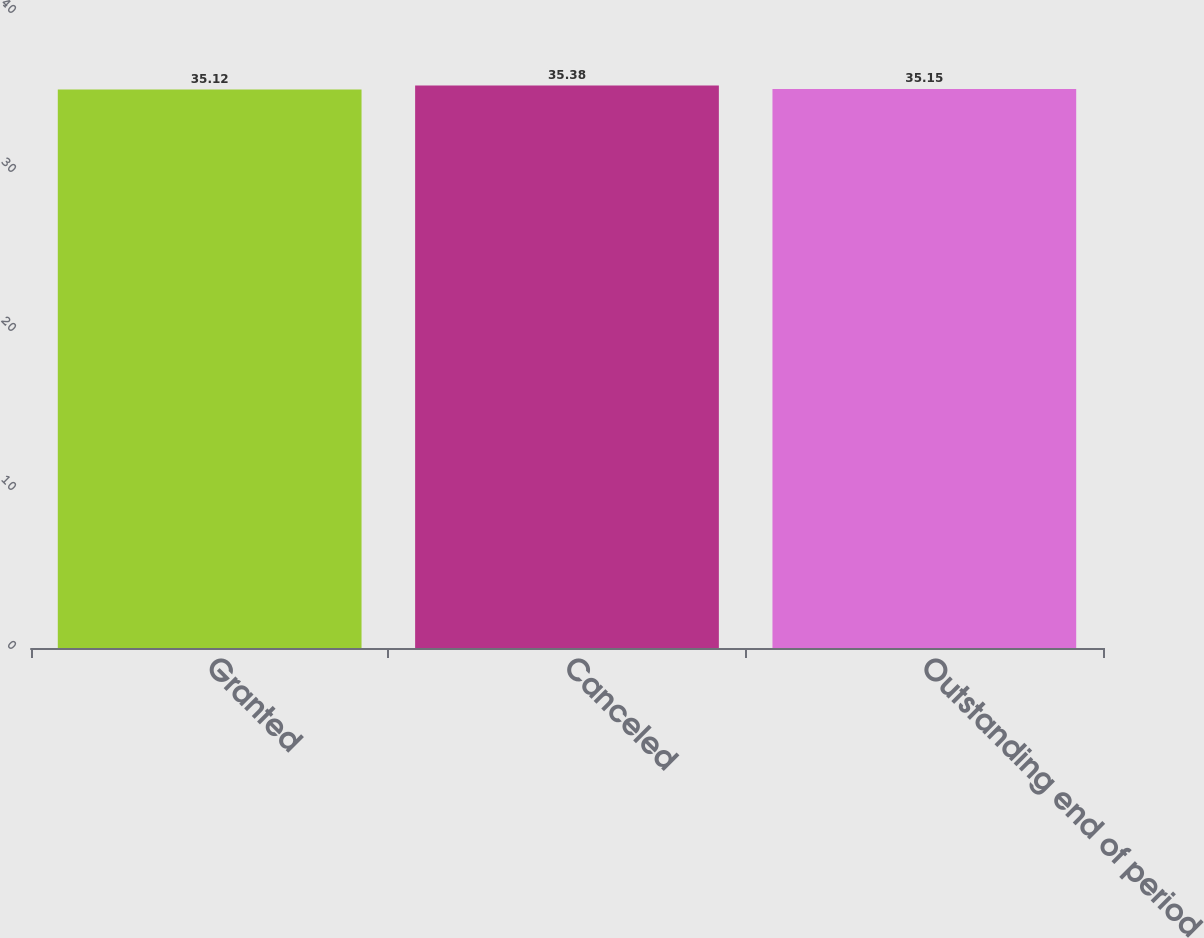Convert chart to OTSL. <chart><loc_0><loc_0><loc_500><loc_500><bar_chart><fcel>Granted<fcel>Canceled<fcel>Outstanding end of period<nl><fcel>35.12<fcel>35.38<fcel>35.15<nl></chart> 